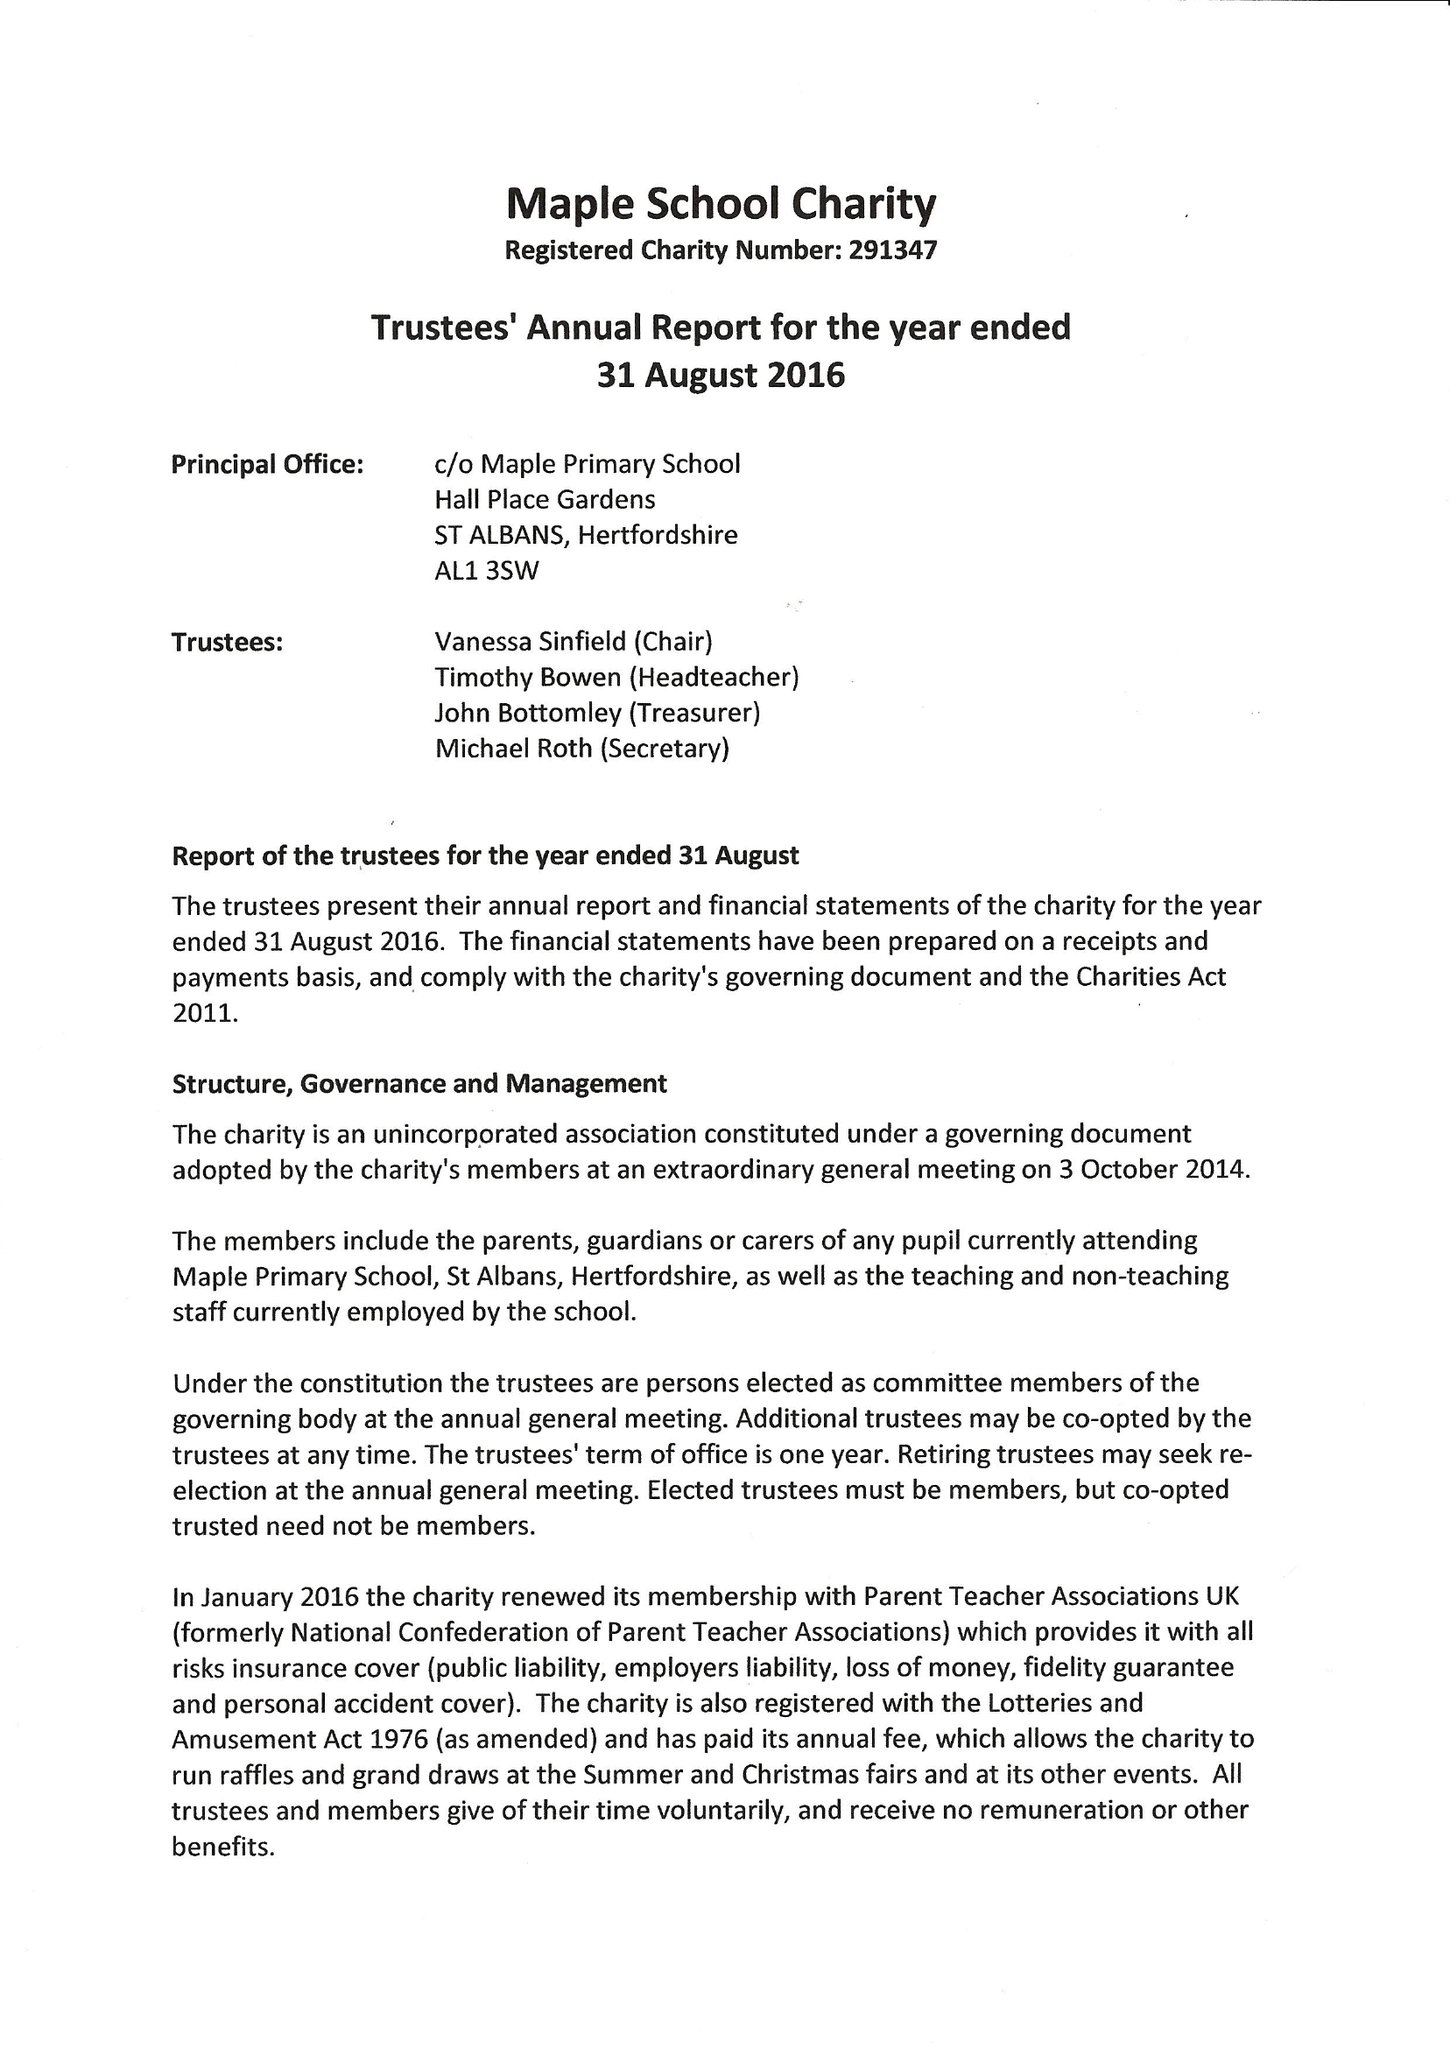What is the value for the charity_number?
Answer the question using a single word or phrase. 291347 